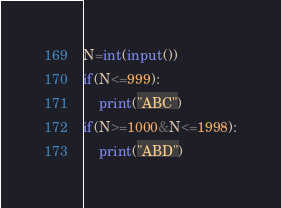Convert code to text. <code><loc_0><loc_0><loc_500><loc_500><_Python_>N=int(input())
if(N<=999):
    print("ABC")
if(N>=1000&N<=1998):
    print("ABD")</code> 